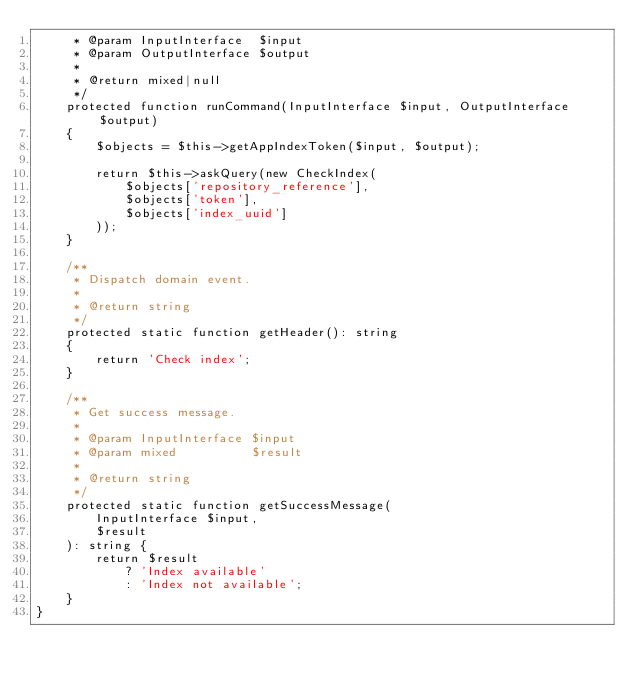<code> <loc_0><loc_0><loc_500><loc_500><_PHP_>     * @param InputInterface  $input
     * @param OutputInterface $output
     *
     * @return mixed|null
     */
    protected function runCommand(InputInterface $input, OutputInterface $output)
    {
        $objects = $this->getAppIndexToken($input, $output);

        return $this->askQuery(new CheckIndex(
            $objects['repository_reference'],
            $objects['token'],
            $objects['index_uuid']
        ));
    }

    /**
     * Dispatch domain event.
     *
     * @return string
     */
    protected static function getHeader(): string
    {
        return 'Check index';
    }

    /**
     * Get success message.
     *
     * @param InputInterface $input
     * @param mixed          $result
     *
     * @return string
     */
    protected static function getSuccessMessage(
        InputInterface $input,
        $result
    ): string {
        return $result
            ? 'Index available'
            : 'Index not available';
    }
}
</code> 